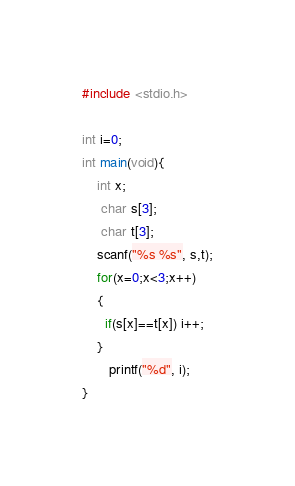<code> <loc_0><loc_0><loc_500><loc_500><_C++_>#include <stdio.h>

int i=0;
int main(void){
    int x;
     char s[3];
     char t[3];
    scanf("%s %s", s,t);
    for(x=0;x<3;x++)
    {
      if(s[x]==t[x]) i++;
    }
       printf("%d", i);
}
</code> 